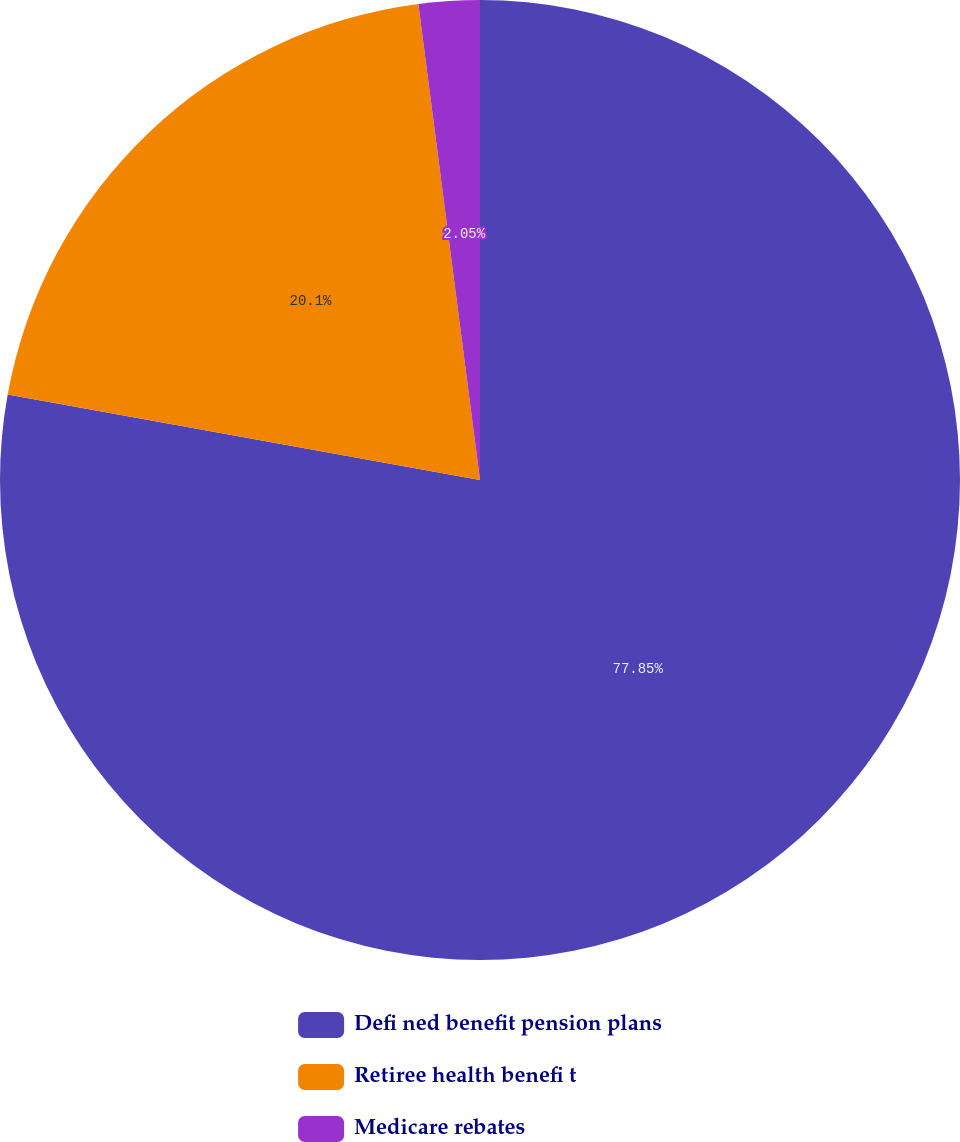Convert chart. <chart><loc_0><loc_0><loc_500><loc_500><pie_chart><fcel>Defi ned benefit pension plans<fcel>Retiree health benefi t<fcel>Medicare rebates<nl><fcel>77.86%<fcel>20.1%<fcel>2.05%<nl></chart> 